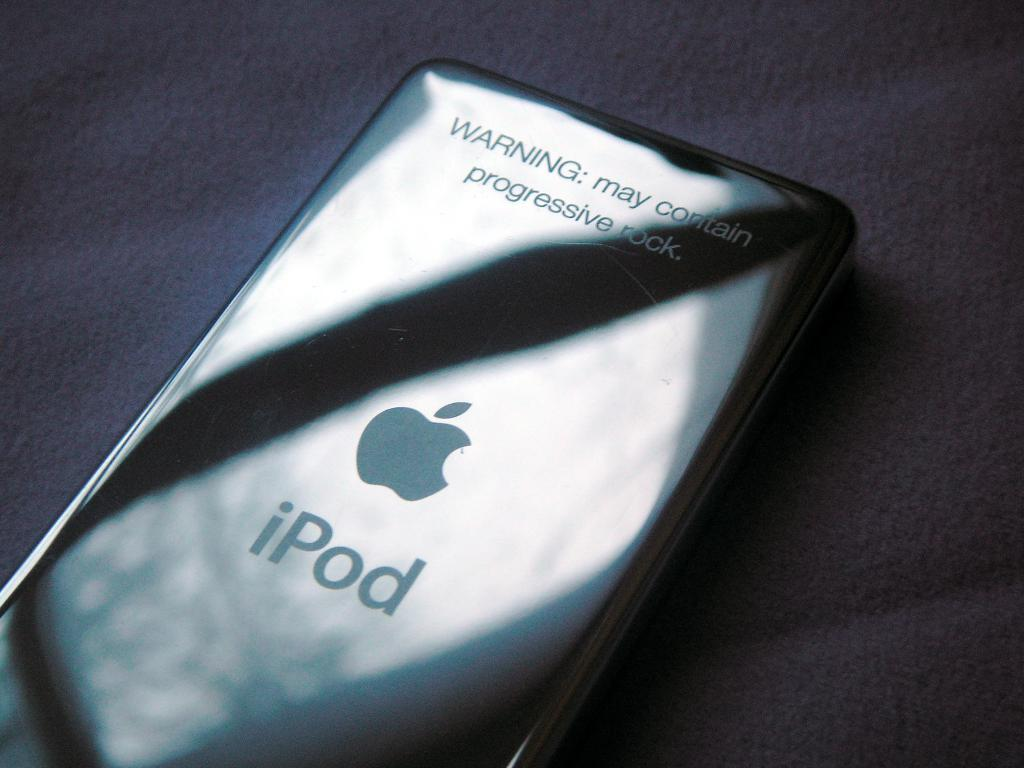<image>
Offer a succinct explanation of the picture presented. A closeup on an iPod that warns it may contain progressive rock. 